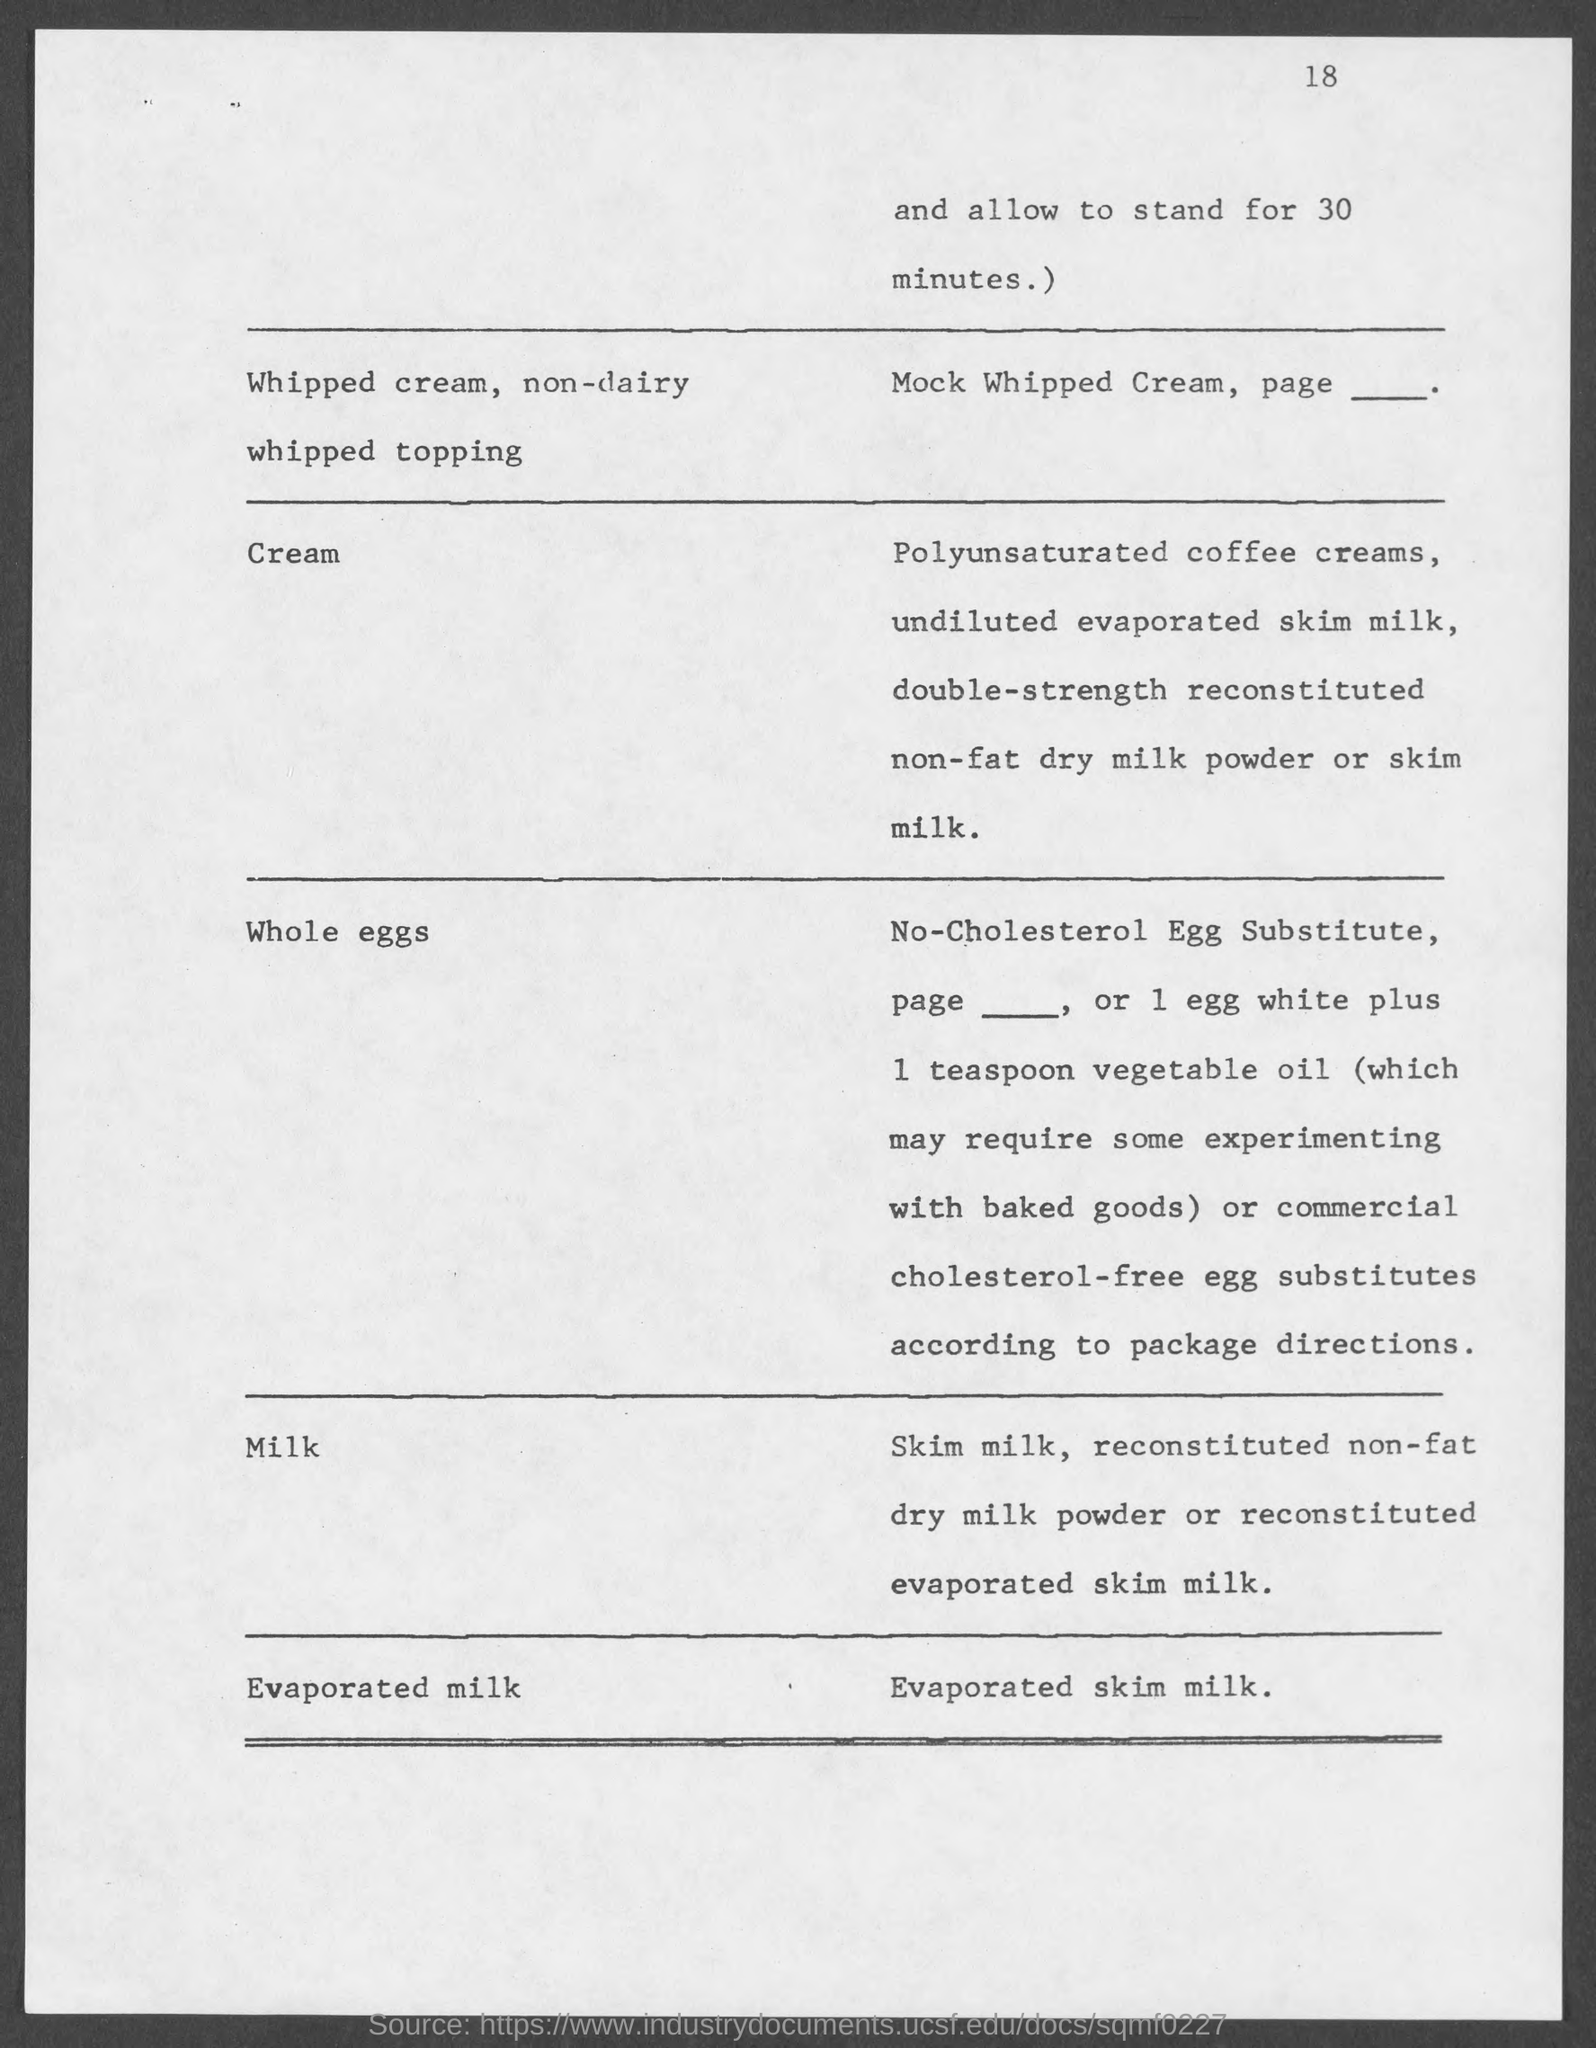Indicate a few pertinent items in this graphic. The number at the top-right corner of the page is 18. 